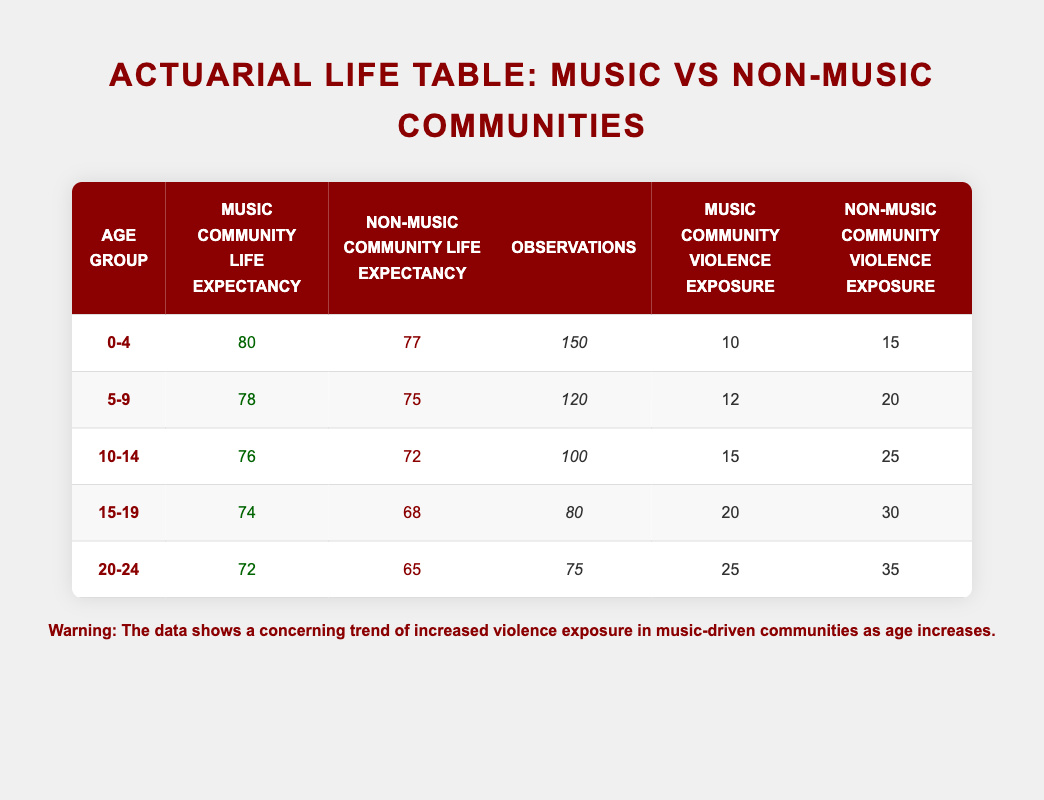What is the life expectancy of youth in the music community aged 15-19? Referring to the table, the life expectancy for this age group in the music community is listed under "Music Community Life Expectancy" for the age group "15-19", which is 74.
Answer: 74 How many observations were made for youth aged 10-14 in non-music communities? The number of observations for the age group "10-14" in non-music communities can be found in the "Observations" column for that age group, which is 100.
Answer: 100 What is the difference in life expectancy between youth in music and non-music communities in the 20-24 age group? To find the difference, subtract the non-music community life expectancy (65) from the music community life expectancy (72) for the 20-24 age group: 72 - 65 = 7.
Answer: 7 Is the violence exposure lower in music-driven communities for the 0-4 age group compared to non-music-driven communities? The table shows a violence exposure of 10 for music-driven communities and 15 for non-music-driven communities in the 0-4 age group. Since 10 is less than 15, the statement is true.
Answer: Yes What is the average life expectancy of youth in music communities across all age groups listed? To calculate the average, sum the life expectancy values for each age group in music communities: 80 + 78 + 76 + 74 + 72 = 380. Then, divide by the number of age groups, which is 5: 380 / 5 = 76.
Answer: 76 What is the total number of observations for youth aged 5-9 and 15-19 in music communities combined? The number of observations in music communities for the age groups "5-9" and "15-19" are 120 and 80, respectively. Adding these gives: 120 + 80 = 200.
Answer: 200 Is there a trend of increasing violence exposure as age increases in non-music communities? Comparing the "Non-Music Community Violence Exposure" across age groups, the values are 15, 20, 25, 30, and 35 respectively. This shows an upward trend as the age increases.
Answer: Yes What is the average violence exposure for the 10-14 age group in both music-driven and non-music-driven communities? For the music community, the violence exposure is 15, while for the non-music community, it is 25. The total is 15 + 25 = 40, and the average is 40 / 2 = 20.
Answer: 20 